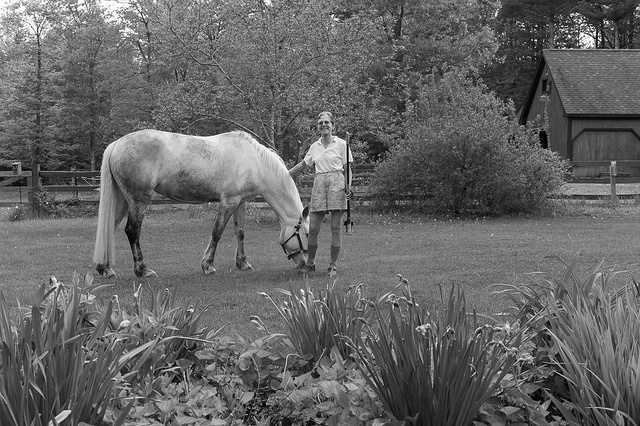Describe the objects in this image and their specific colors. I can see horse in white, darkgray, gray, lightgray, and black tones and people in white, gray, darkgray, lightgray, and black tones in this image. 